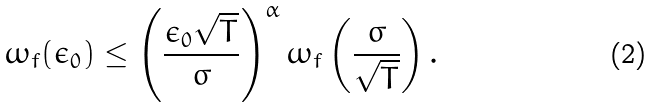<formula> <loc_0><loc_0><loc_500><loc_500>\omega _ { f } ( \epsilon _ { 0 } ) \leq \left ( \frac { \epsilon _ { 0 } \sqrt { T } } { \sigma } \right ) ^ { \alpha } \omega _ { f } \left ( \frac { \sigma } { \sqrt { T } } \right ) .</formula> 